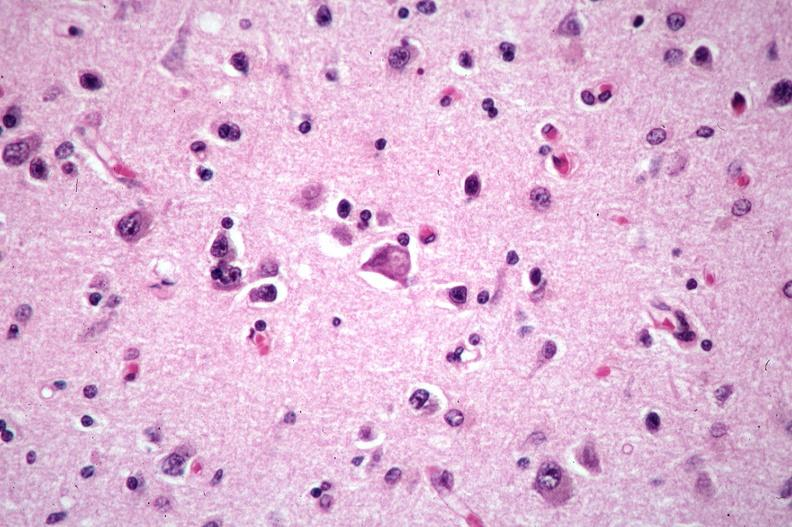what is present?
Answer the question using a single word or phrase. Nervous 